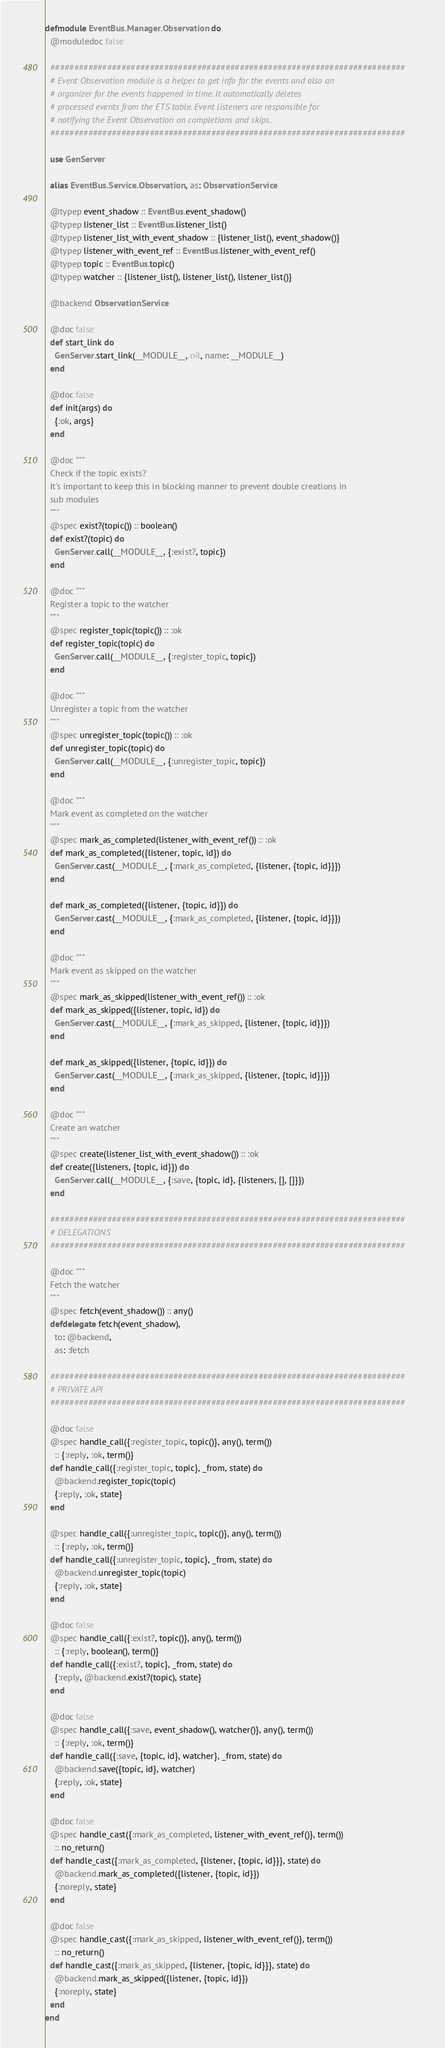Convert code to text. <code><loc_0><loc_0><loc_500><loc_500><_Elixir_>defmodule EventBus.Manager.Observation do
  @moduledoc false

  ###########################################################################
  # Event Observation module is a helper to get info for the events and also an
  # organizer for the events happened in time. It automatically deletes
  # processed events from the ETS table. Event listeners are responsible for
  # notifying the Event Observation on completions and skips.
  ###########################################################################

  use GenServer

  alias EventBus.Service.Observation, as: ObservationService

  @typep event_shadow :: EventBus.event_shadow()
  @typep listener_list :: EventBus.listener_list()
  @typep listener_list_with_event_shadow :: {listener_list(), event_shadow()}
  @typep listener_with_event_ref :: EventBus.listener_with_event_ref()
  @typep topic :: EventBus.topic()
  @typep watcher :: {listener_list(), listener_list(), listener_list()}

  @backend ObservationService

  @doc false
  def start_link do
    GenServer.start_link(__MODULE__, nil, name: __MODULE__)
  end

  @doc false
  def init(args) do
    {:ok, args}
  end

  @doc """
  Check if the topic exists?
  It's important to keep this in blocking manner to prevent double creations in
  sub modules
  """
  @spec exist?(topic()) :: boolean()
  def exist?(topic) do
    GenServer.call(__MODULE__, {:exist?, topic})
  end

  @doc """
  Register a topic to the watcher
  """
  @spec register_topic(topic()) :: :ok
  def register_topic(topic) do
    GenServer.call(__MODULE__, {:register_topic, topic})
  end

  @doc """
  Unregister a topic from the watcher
  """
  @spec unregister_topic(topic()) :: :ok
  def unregister_topic(topic) do
    GenServer.call(__MODULE__, {:unregister_topic, topic})
  end

  @doc """
  Mark event as completed on the watcher
  """
  @spec mark_as_completed(listener_with_event_ref()) :: :ok
  def mark_as_completed({listener, topic, id}) do
    GenServer.cast(__MODULE__, {:mark_as_completed, {listener, {topic, id}}})
  end

  def mark_as_completed({listener, {topic, id}}) do
    GenServer.cast(__MODULE__, {:mark_as_completed, {listener, {topic, id}}})
  end

  @doc """
  Mark event as skipped on the watcher
  """
  @spec mark_as_skipped(listener_with_event_ref()) :: :ok
  def mark_as_skipped({listener, topic, id}) do
    GenServer.cast(__MODULE__, {:mark_as_skipped, {listener, {topic, id}}})
  end

  def mark_as_skipped({listener, {topic, id}}) do
    GenServer.cast(__MODULE__, {:mark_as_skipped, {listener, {topic, id}}})
  end

  @doc """
  Create an watcher
  """
  @spec create(listener_list_with_event_shadow()) :: :ok
  def create({listeners, {topic, id}}) do
    GenServer.call(__MODULE__, {:save, {topic, id}, {listeners, [], []}})
  end

  ###########################################################################
  # DELEGATIONS
  ###########################################################################

  @doc """
  Fetch the watcher
  """
  @spec fetch(event_shadow()) :: any()
  defdelegate fetch(event_shadow),
    to: @backend,
    as: :fetch

  ###########################################################################
  # PRIVATE API
  ###########################################################################

  @doc false
  @spec handle_call({:register_topic, topic()}, any(), term())
    :: {:reply, :ok, term()}
  def handle_call({:register_topic, topic}, _from, state) do
    @backend.register_topic(topic)
    {:reply, :ok, state}
  end

  @spec handle_call({:unregister_topic, topic()}, any(), term())
    :: {:reply, :ok, term()}
  def handle_call({:unregister_topic, topic}, _from, state) do
    @backend.unregister_topic(topic)
    {:reply, :ok, state}
  end

  @doc false
  @spec handle_call({:exist?, topic()}, any(), term())
    :: {:reply, boolean(), term()}
  def handle_call({:exist?, topic}, _from, state) do
    {:reply, @backend.exist?(topic), state}
  end

  @doc false
  @spec handle_call({:save, event_shadow(), watcher()}, any(), term())
    :: {:reply, :ok, term()}
  def handle_call({:save, {topic, id}, watcher}, _from, state) do
    @backend.save({topic, id}, watcher)
    {:reply, :ok, state}
  end

  @doc false
  @spec handle_cast({:mark_as_completed, listener_with_event_ref()}, term())
    :: no_return()
  def handle_cast({:mark_as_completed, {listener, {topic, id}}}, state) do
    @backend.mark_as_completed({listener, {topic, id}})
    {:noreply, state}
  end

  @doc false
  @spec handle_cast({:mark_as_skipped, listener_with_event_ref()}, term())
    :: no_return()
  def handle_cast({:mark_as_skipped, {listener, {topic, id}}}, state) do
    @backend.mark_as_skipped({listener, {topic, id}})
    {:noreply, state}
  end
end
</code> 